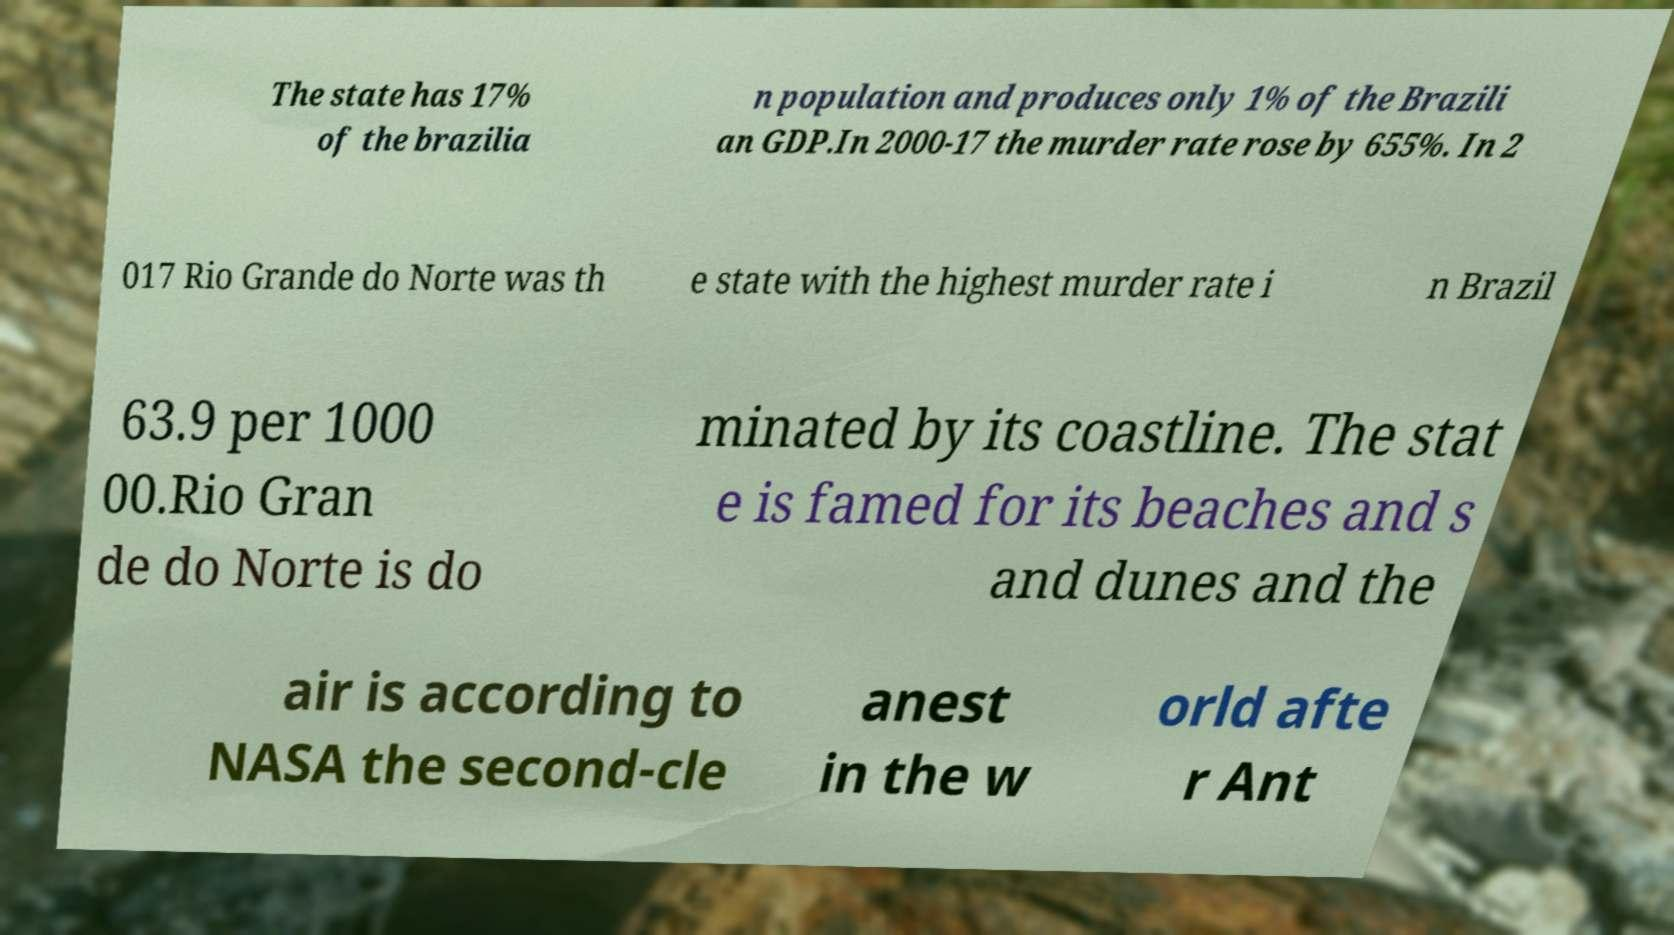Please identify and transcribe the text found in this image. The state has 17% of the brazilia n population and produces only 1% of the Brazili an GDP.In 2000-17 the murder rate rose by 655%. In 2 017 Rio Grande do Norte was th e state with the highest murder rate i n Brazil 63.9 per 1000 00.Rio Gran de do Norte is do minated by its coastline. The stat e is famed for its beaches and s and dunes and the air is according to NASA the second-cle anest in the w orld afte r Ant 